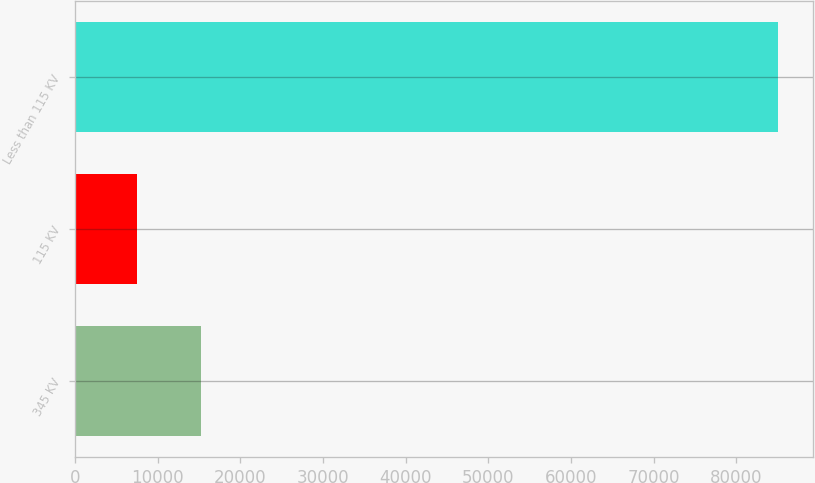Convert chart to OTSL. <chart><loc_0><loc_0><loc_500><loc_500><bar_chart><fcel>345 KV<fcel>115 KV<fcel>Less than 115 KV<nl><fcel>15272.1<fcel>7517<fcel>85068<nl></chart> 